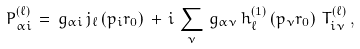Convert formula to latex. <formula><loc_0><loc_0><loc_500><loc_500>P ^ { ( \ell ) } _ { \alpha i } \, = \, g _ { \alpha i } \, j _ { \ell } \left ( p _ { i } r _ { 0 } \right ) \, + \, i \, \sum _ { \nu } \, g _ { \alpha \nu } \, h ^ { ( 1 ) } _ { \ell } \left ( p _ { \nu } r _ { 0 } \right ) \, T ^ { ( \ell ) } _ { i \nu } \, ,</formula> 